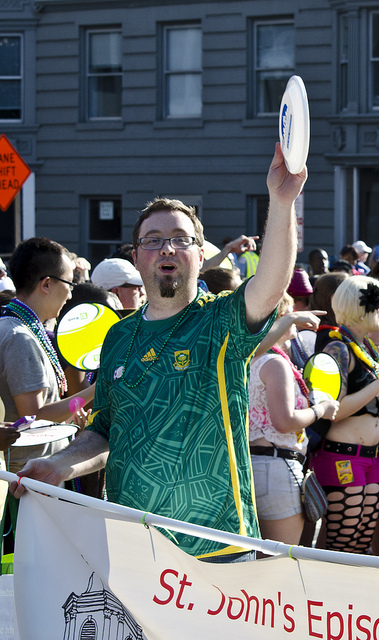Extract all visible text content from this image. St. John's Epis NE IFT EAD 